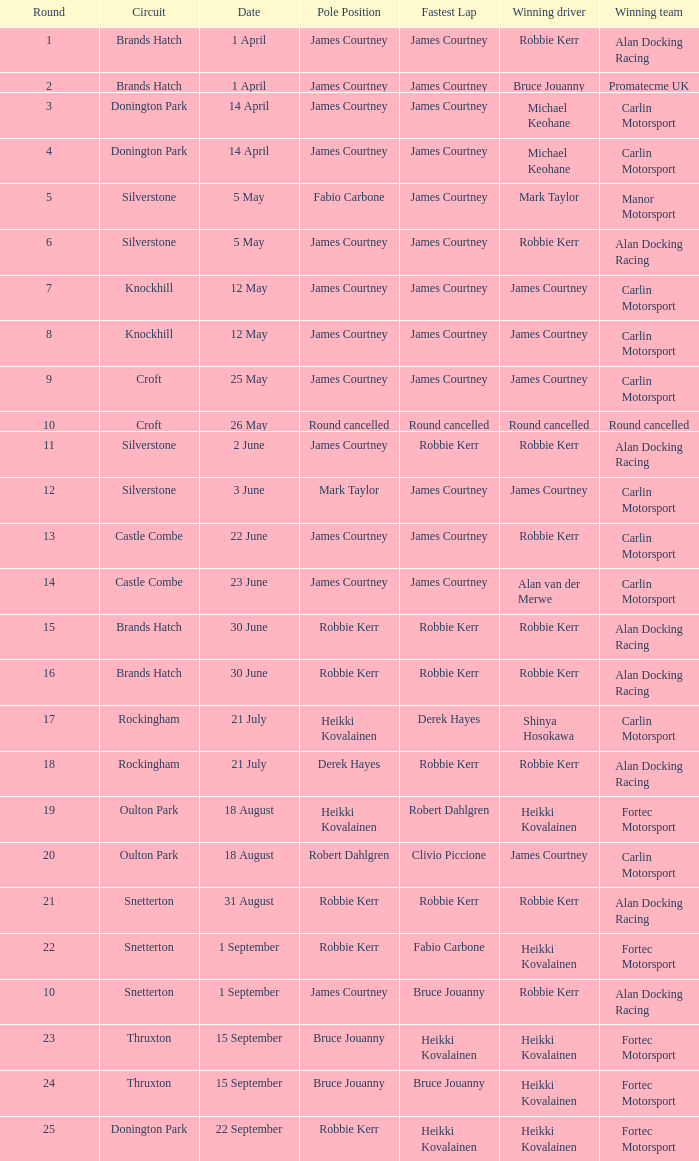Which drivers are the winners when the successful team is carlin motorsport and the course is croft? James Courtney. 